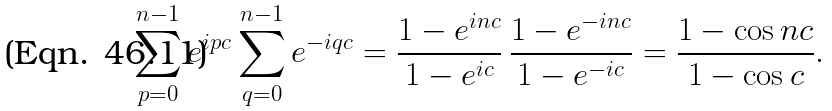Convert formula to latex. <formula><loc_0><loc_0><loc_500><loc_500>\sum _ { p = 0 } ^ { n - 1 } e ^ { i p c } \sum _ { q = 0 } ^ { n - 1 } e ^ { - i q c } = \frac { 1 - e ^ { i n c } } { 1 - e ^ { i c } } \, \frac { 1 - e ^ { - i n c } } { 1 - e ^ { - i c } } = \frac { 1 - \cos n c } { 1 - \cos c } .</formula> 